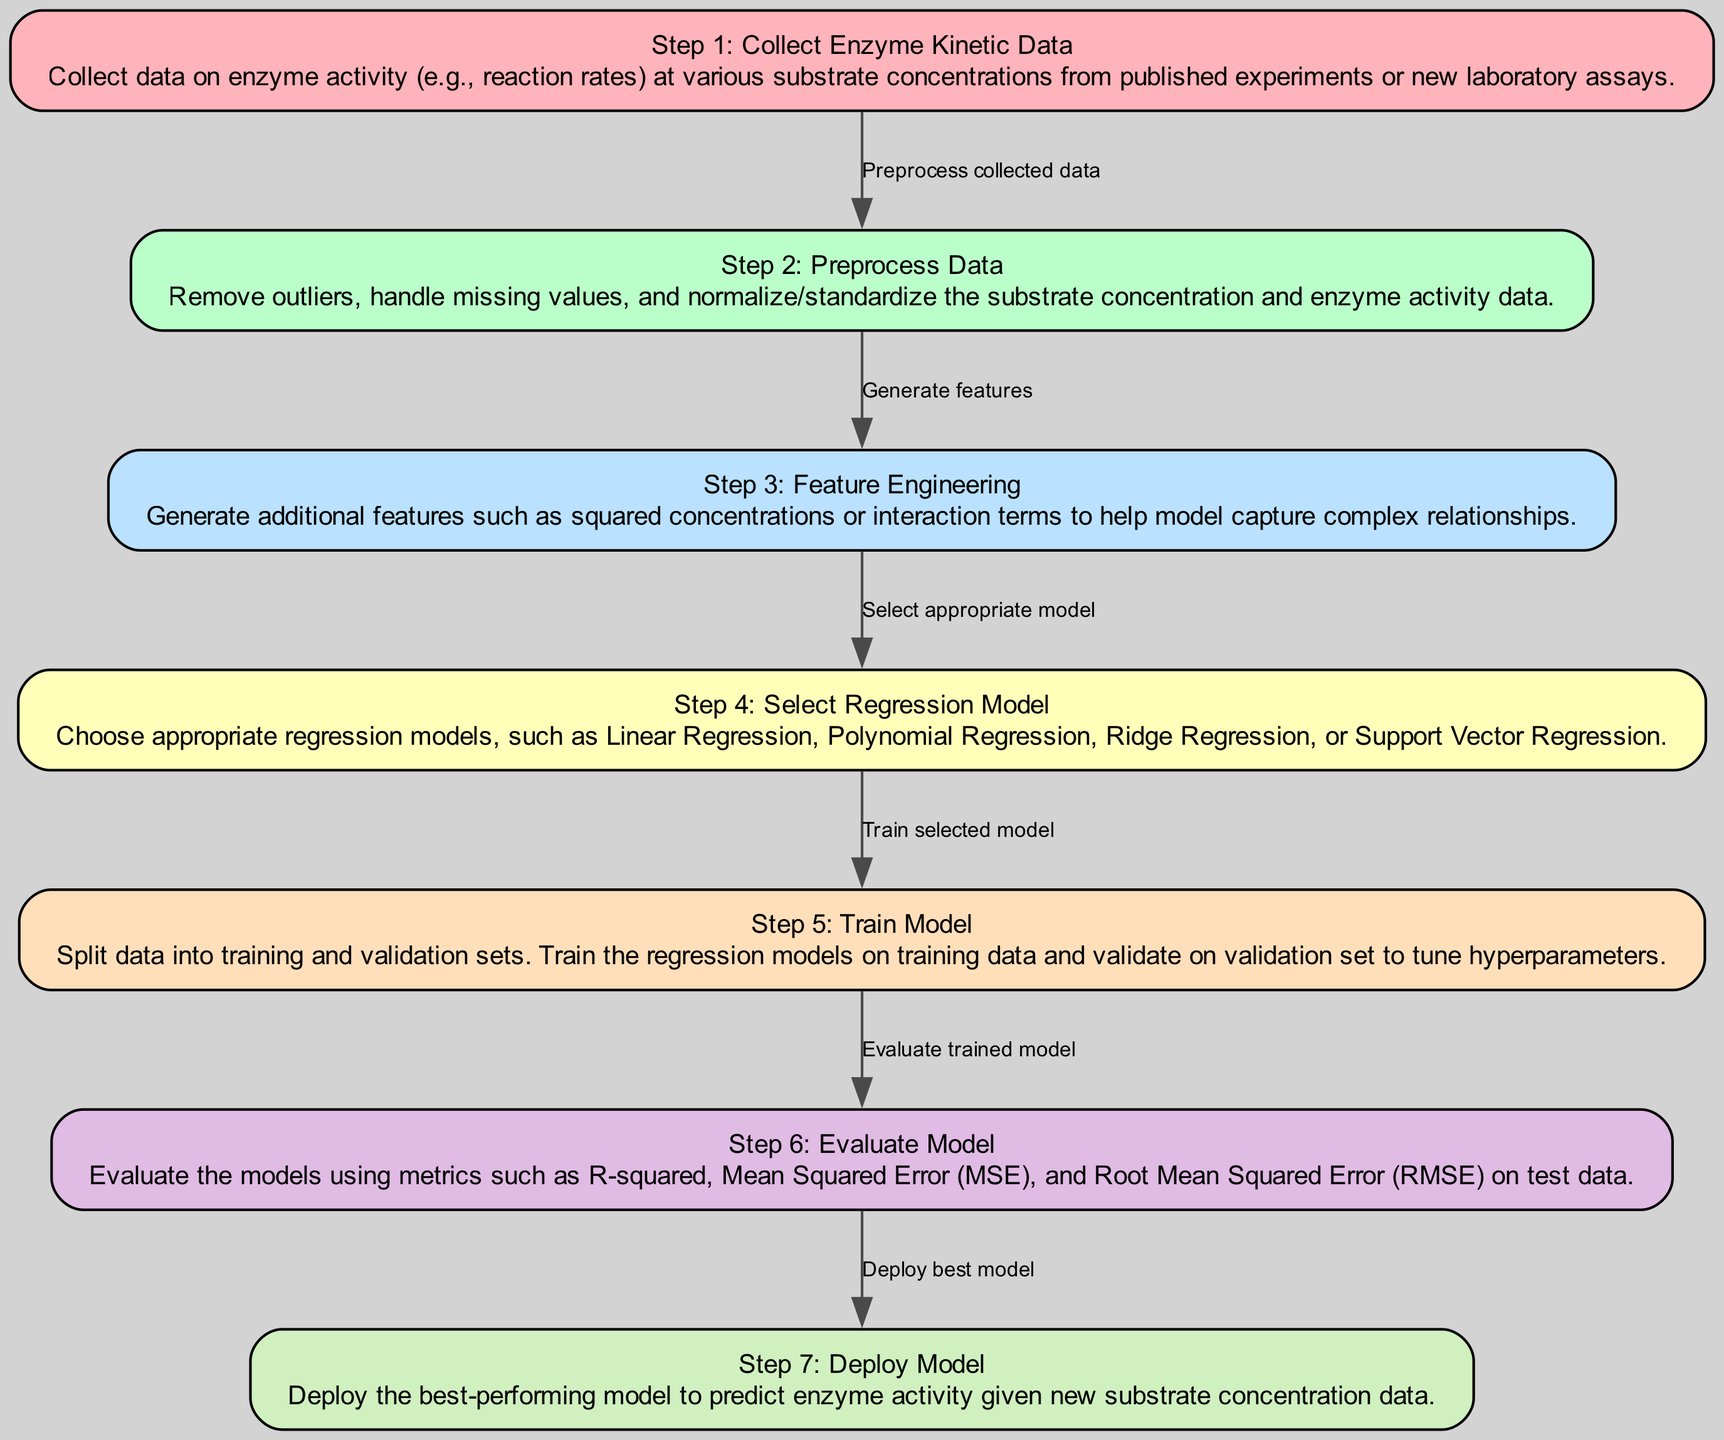What is the first step in the diagram? The first step is labeled "Step 1: Collect Enzyme Kinetic Data," which describes the process of collecting data on enzyme activity at various substrate concentrations. This information can be found in the node labeled "Raw Data Collection."
Answer: Collect Enzyme Kinetic Data How many steps are listed in the diagram? By counting the nodes representing the steps, there are a total of seven steps labeled from Step 1 to Step 7.
Answer: Seven Which step involves preprocessing the collected data? The step labeled "Step 2: Preprocess Data" focuses on removing outliers, handling missing values, and normalizing data. This corresponds to the node named "Data Preprocessing."
Answer: Step 2: Preprocess Data What type of model is selected in Step 4? In Step 4, the appropriate model is selected, which can include Linear Regression, Polynomial Regression, Ridge Regression, or Support Vector Regression. This is detailed in the node labeled "Model Selection."
Answer: Regression model What is the purpose of the edges connecting the nodes? The edges in the diagram demonstrate the flow of the machine learning process, indicating how each step is related to the next, such as "Preprocess collected data" connecting Step 1 and Step 2.
Answer: Flow of the process What metric is used to evaluate the model in Step 6? In Step 6, the evaluation metrics mentioned include R-squared, Mean Squared Error (MSE), and Root Mean Squared Error (RMSE). This evaluation is important for assessing model performance.
Answer: R-squared Which step involves generating additional features for modeling? Step 3 focuses on generating additional features through feature engineering, which helps capture complex relationships. This is described in the node "Feature Engineering."
Answer: Step 3: Feature Engineering Which step comes after training the model? After training the model in Step 5, the next step is Step 6, which involves evaluating the trained model. This sequence is indicated by the connected edges in the diagram.
Answer: Step 6: Evaluate Model What is the final step in the diagram? The final step is labeled "Step 7: Deploy Model," which describes deploying the best-performing model to make predictions based on new substrate concentration data. This is shown in the "Model Deployment" node.
Answer: Deploy Model 